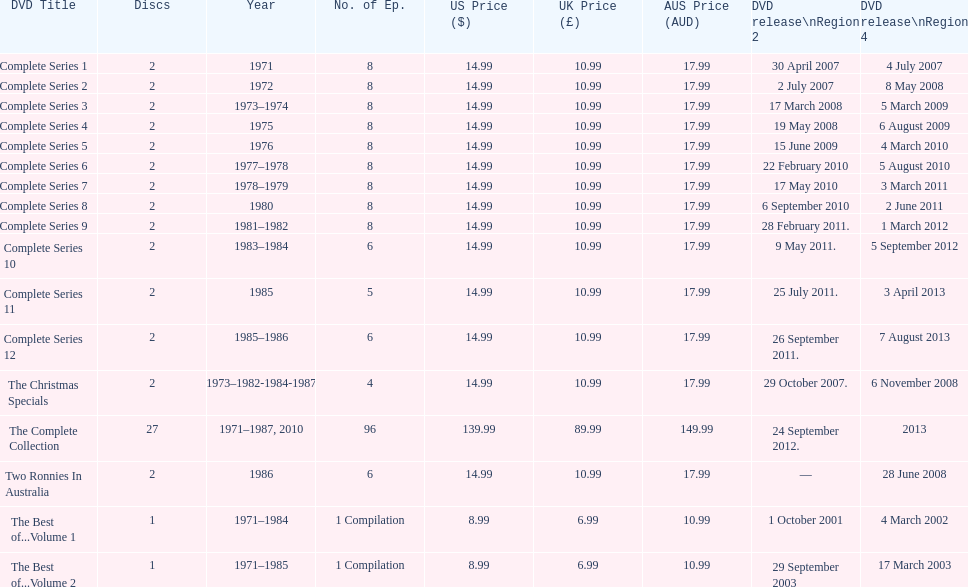Total number of episodes released in region 2 in 2007 20. 